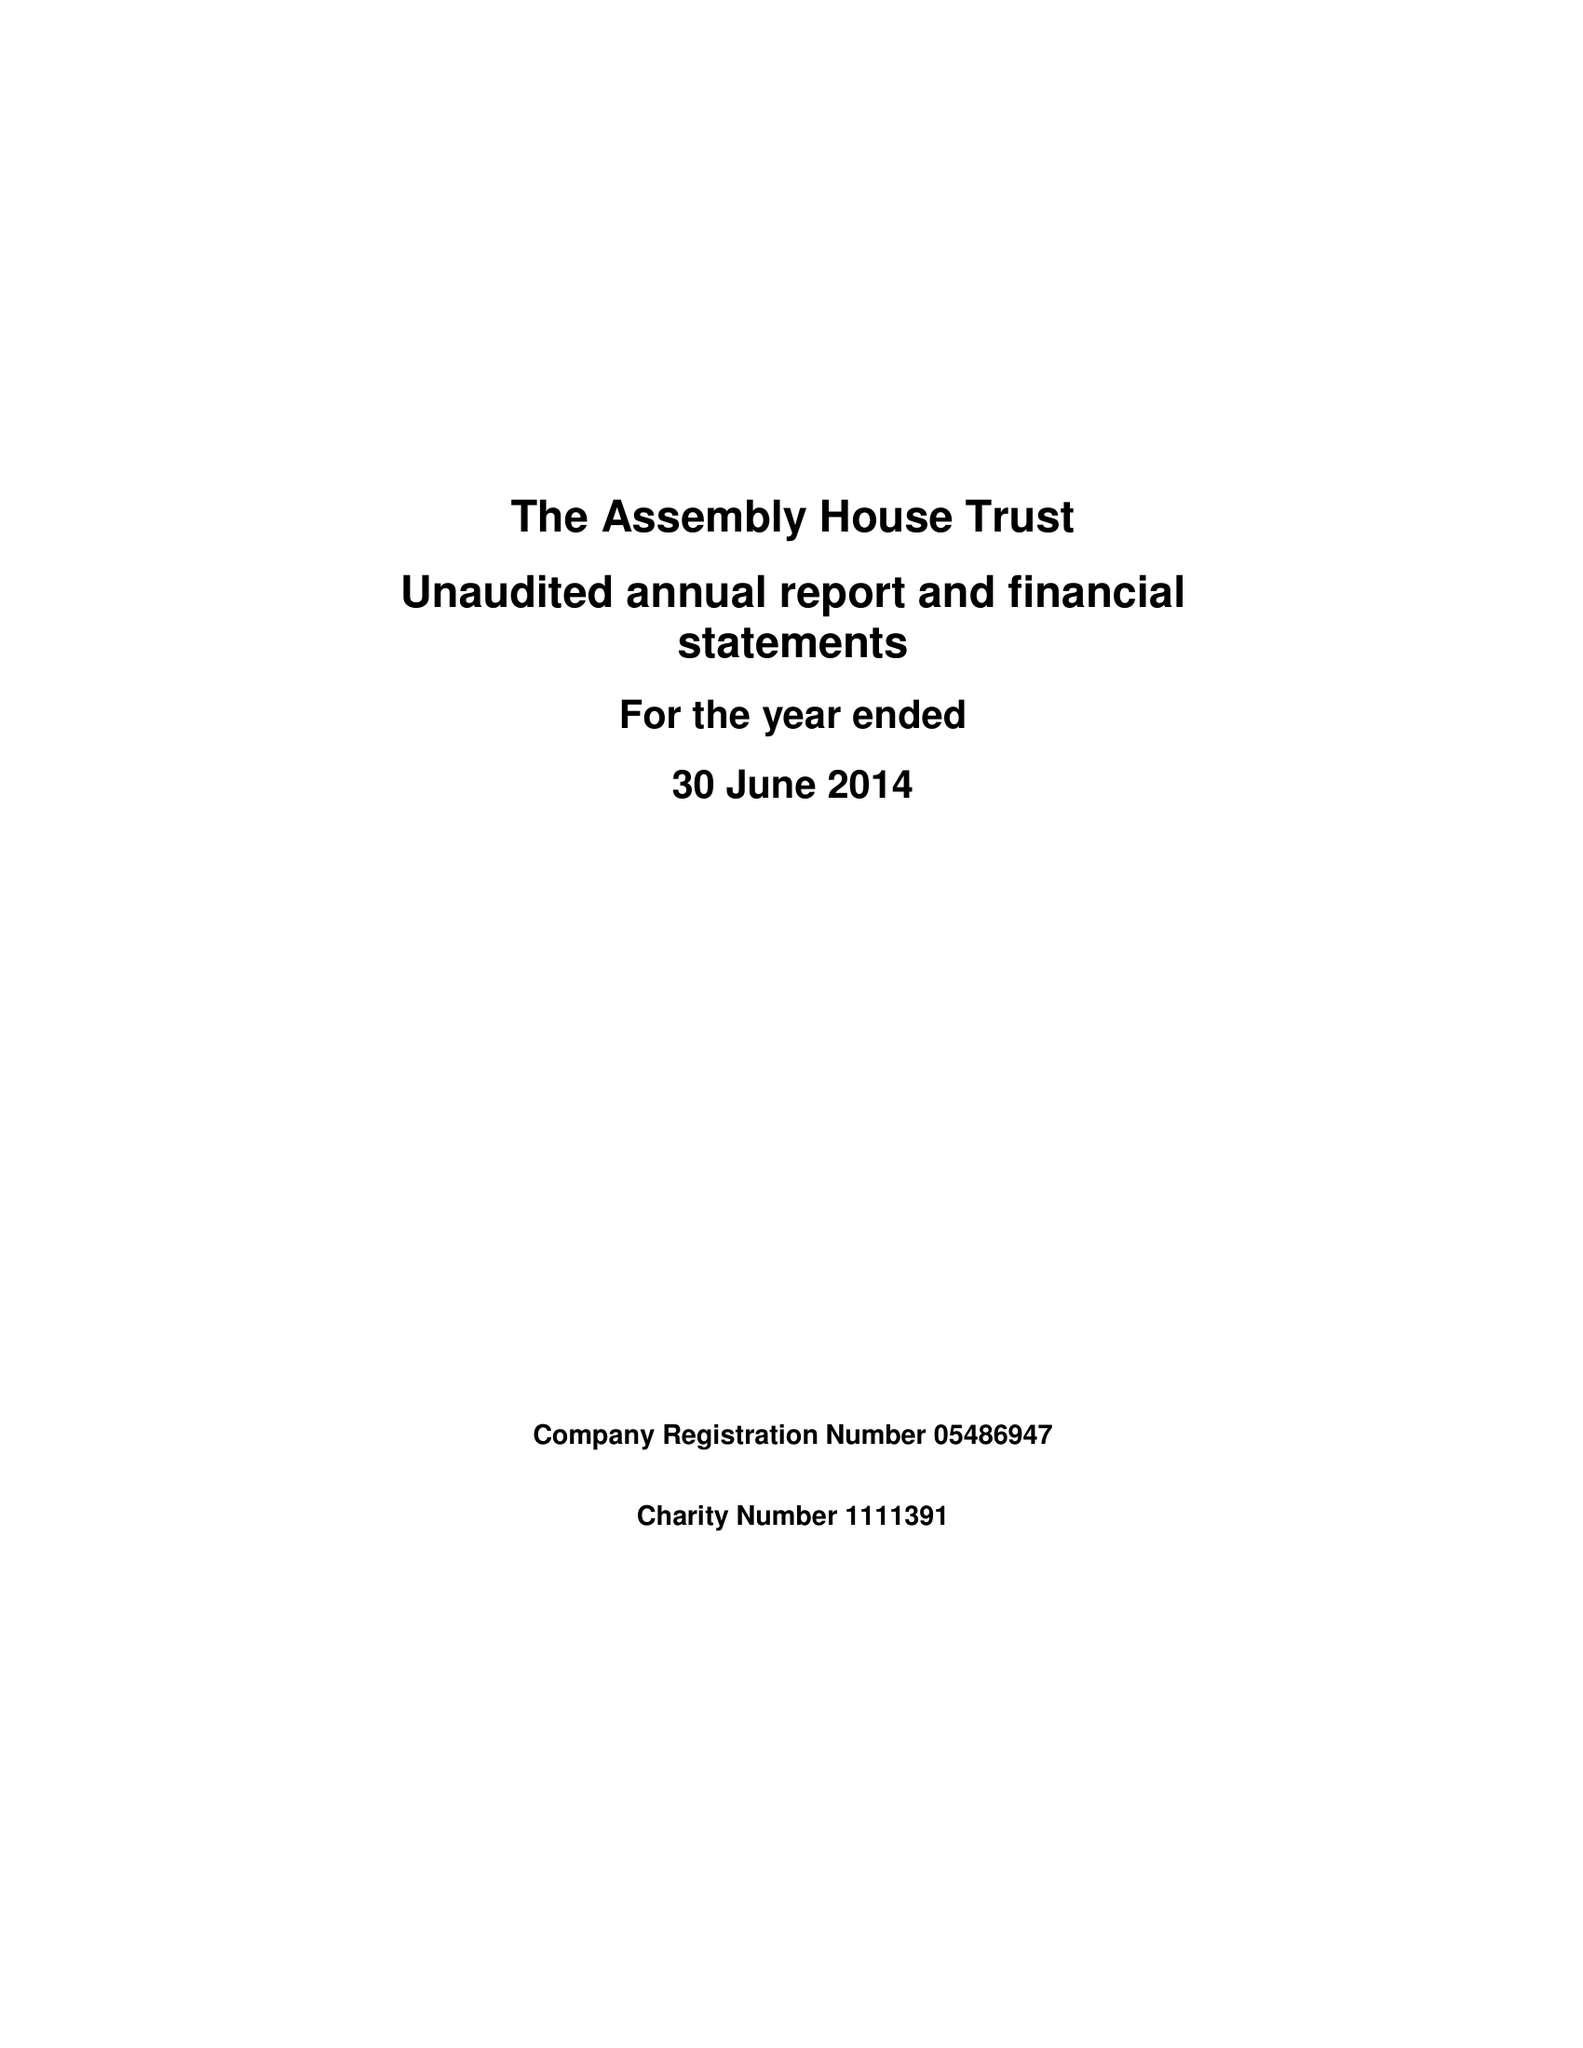What is the value for the charity_number?
Answer the question using a single word or phrase. 1111391 